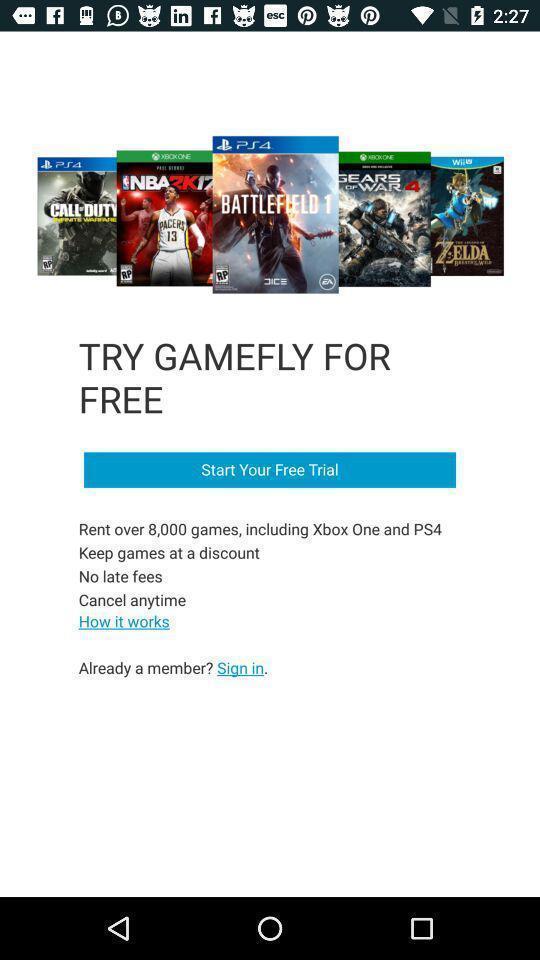What details can you identify in this image? Screen showing to start free trail in gaming. 